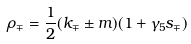<formula> <loc_0><loc_0><loc_500><loc_500>\rho _ { \mp } = \frac { 1 } { 2 } ( \sl k _ { \mp } \pm m ) ( 1 + \gamma _ { 5 } \sl s _ { \mp } )</formula> 